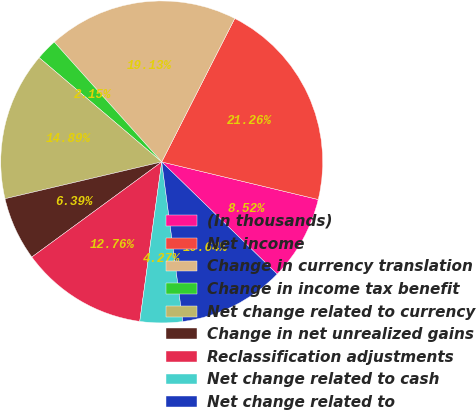Convert chart to OTSL. <chart><loc_0><loc_0><loc_500><loc_500><pie_chart><fcel>(In thousands)<fcel>Net income<fcel>Change in currency translation<fcel>Change in income tax benefit<fcel>Net change related to currency<fcel>Change in net unrealized gains<fcel>Reclassification adjustments<fcel>Net change related to cash<fcel>Net change related to<nl><fcel>8.52%<fcel>21.26%<fcel>19.13%<fcel>2.15%<fcel>14.89%<fcel>6.39%<fcel>12.76%<fcel>4.27%<fcel>10.64%<nl></chart> 